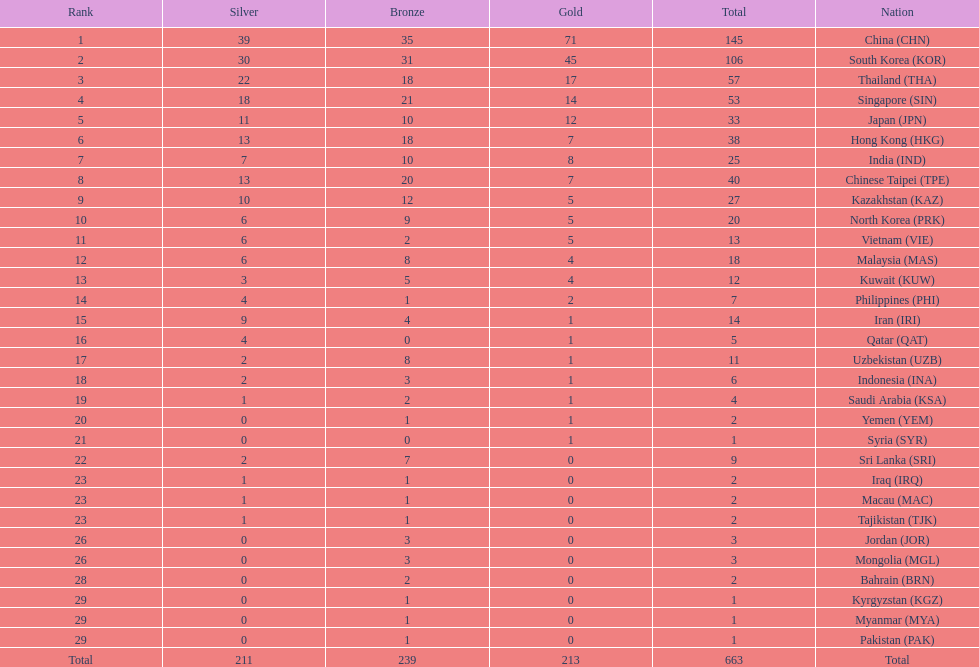What was the total count of medals iran received? 14. 